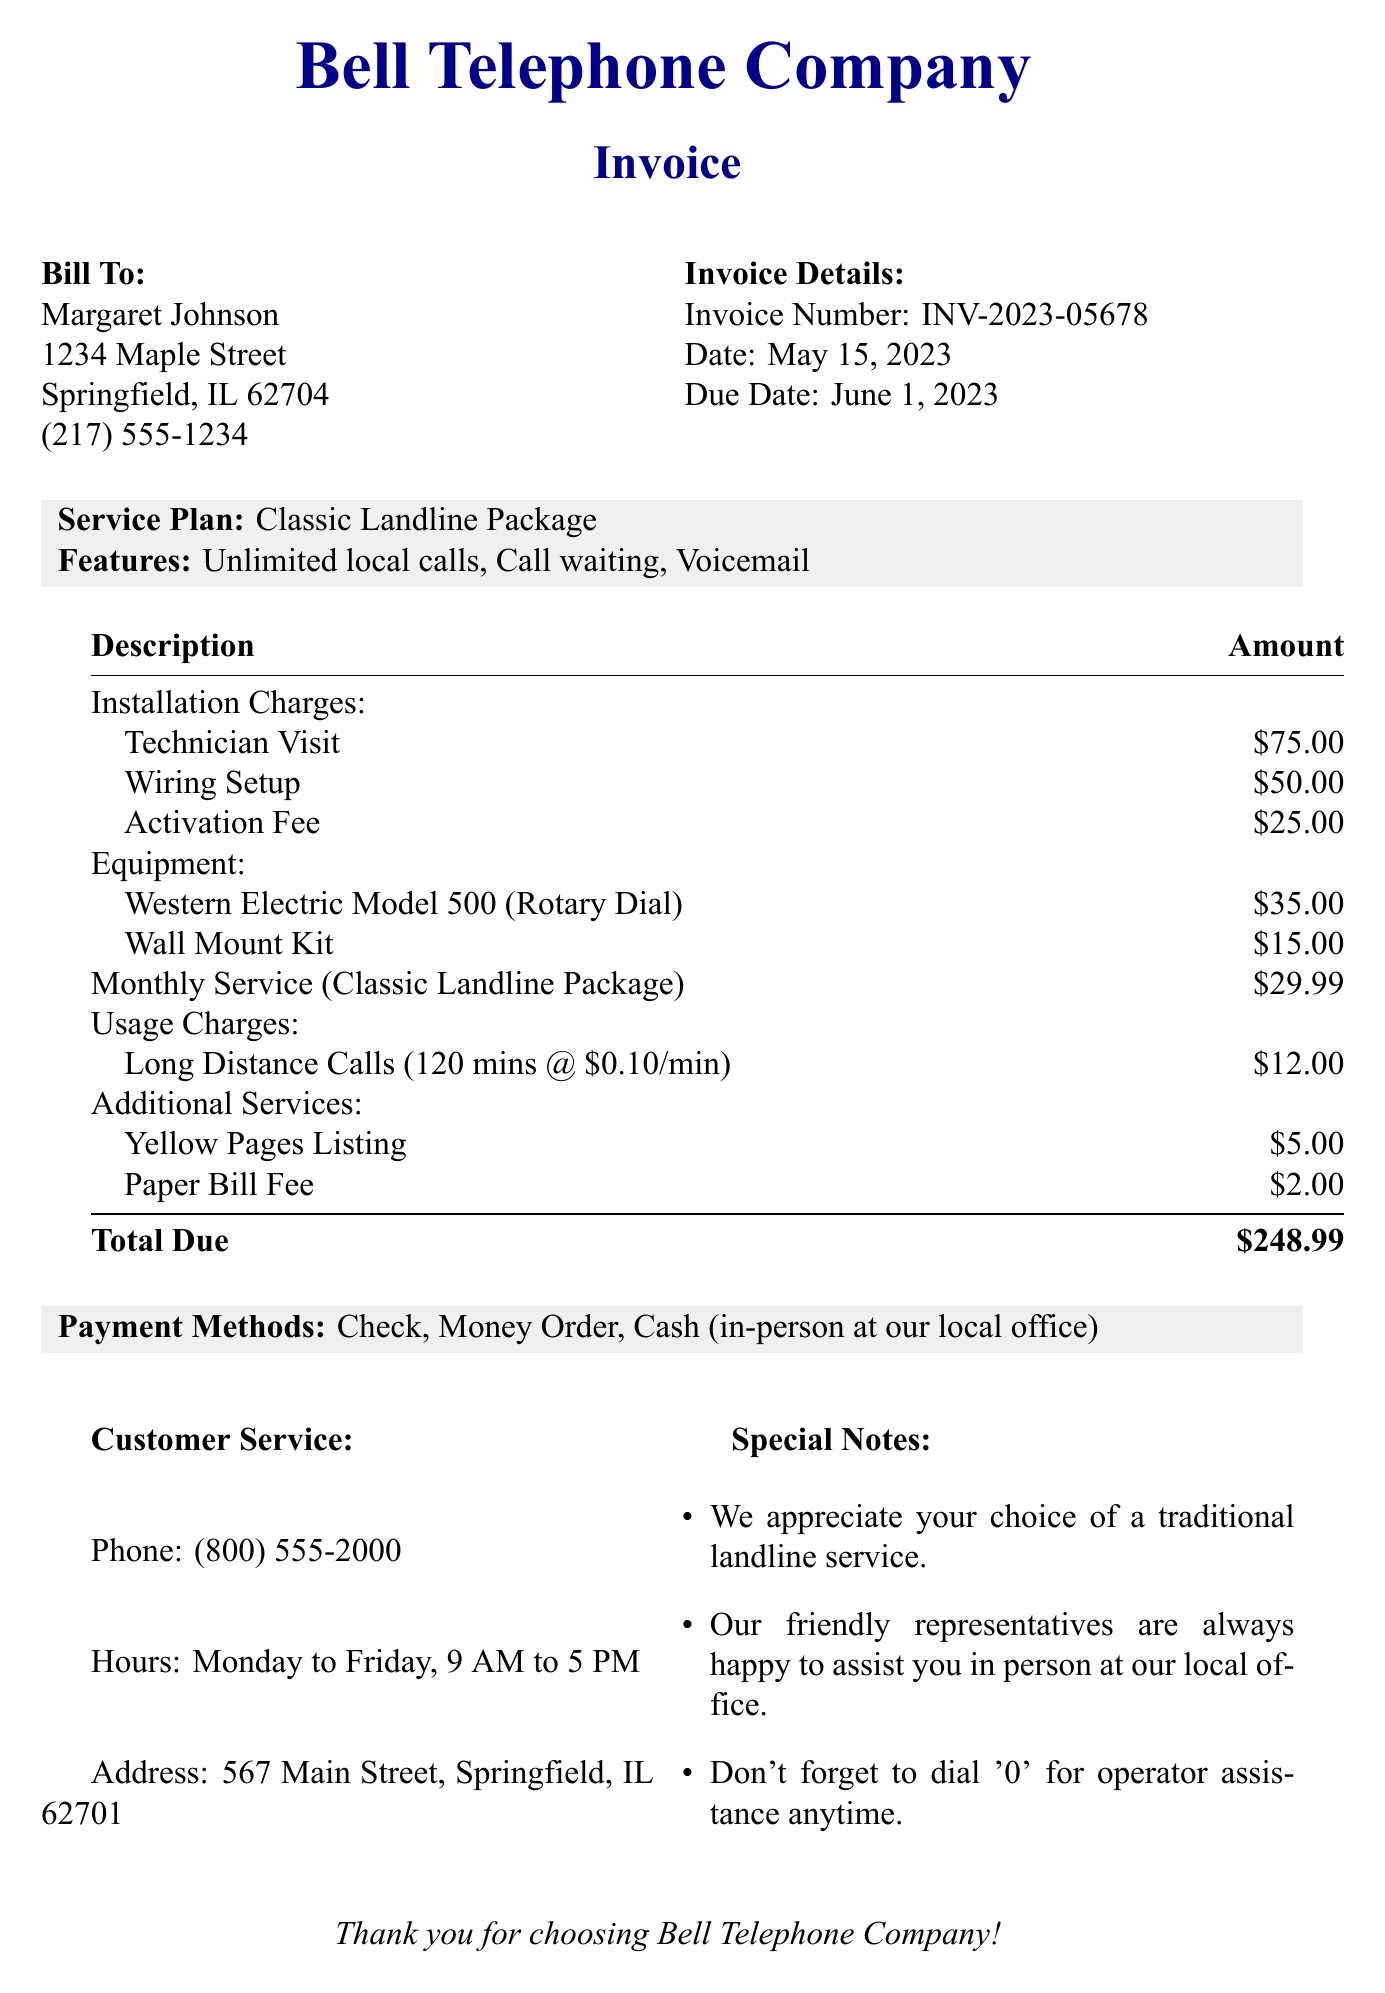What is the invoice number? The invoice number is listed under the invoice details section of the document.
Answer: INV-2023-05678 What is the total due amount? The total due amount is calculated at the bottom of the charges.
Answer: $248.99 What is the name of the monthly service plan? The name of the monthly service plan is mentioned in the service plan section.
Answer: Classic Landline Package How much is the activation fee? The activation fee is part of the installation charges section.
Answer: $25.00 What are the customer service hours? The customer service hours are specified under the customer service section.
Answer: Monday to Friday, 9 AM to 5 PM What is the price of the rotary dial telephone? The price of the rotary dial telephone can be found in the equipment fees section.
Answer: $35.00 How many long-distance minutes were used? The total minutes for long-distance calls is detailed under the usage charges.
Answer: 120 What methods of payment are accepted? The payment methods are listed in a dedicated section of the document.
Answer: Check, Money Order, Cash (in-person at our local office) What additional service incurs a fee of $5.00? The additional services are listed, indicating which one corresponds to this fee.
Answer: Yellow Pages Listing 